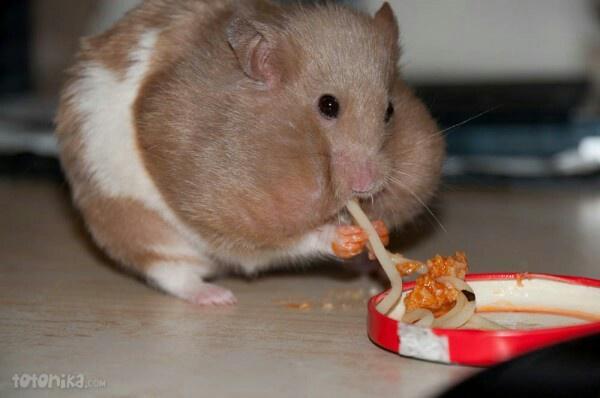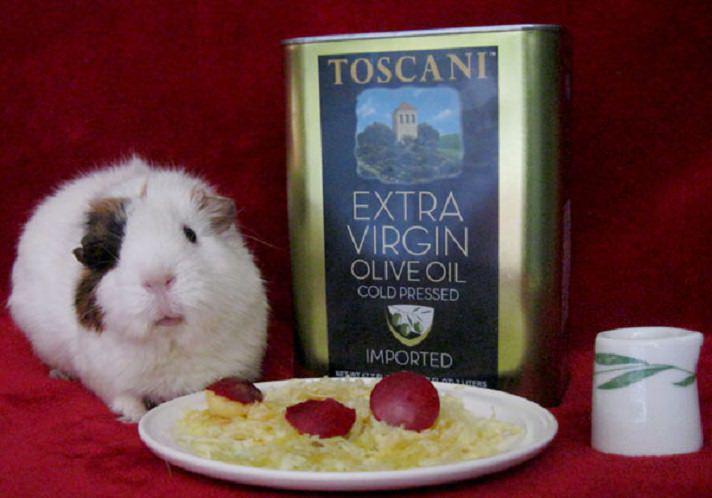The first image is the image on the left, the second image is the image on the right. Examine the images to the left and right. Is the description "A rodent is eating pasta in the left image." accurate? Answer yes or no. Yes. The first image is the image on the left, the second image is the image on the right. For the images shown, is this caption "The rodent in the image on the left sits on a surface to eat noodles." true? Answer yes or no. Yes. 